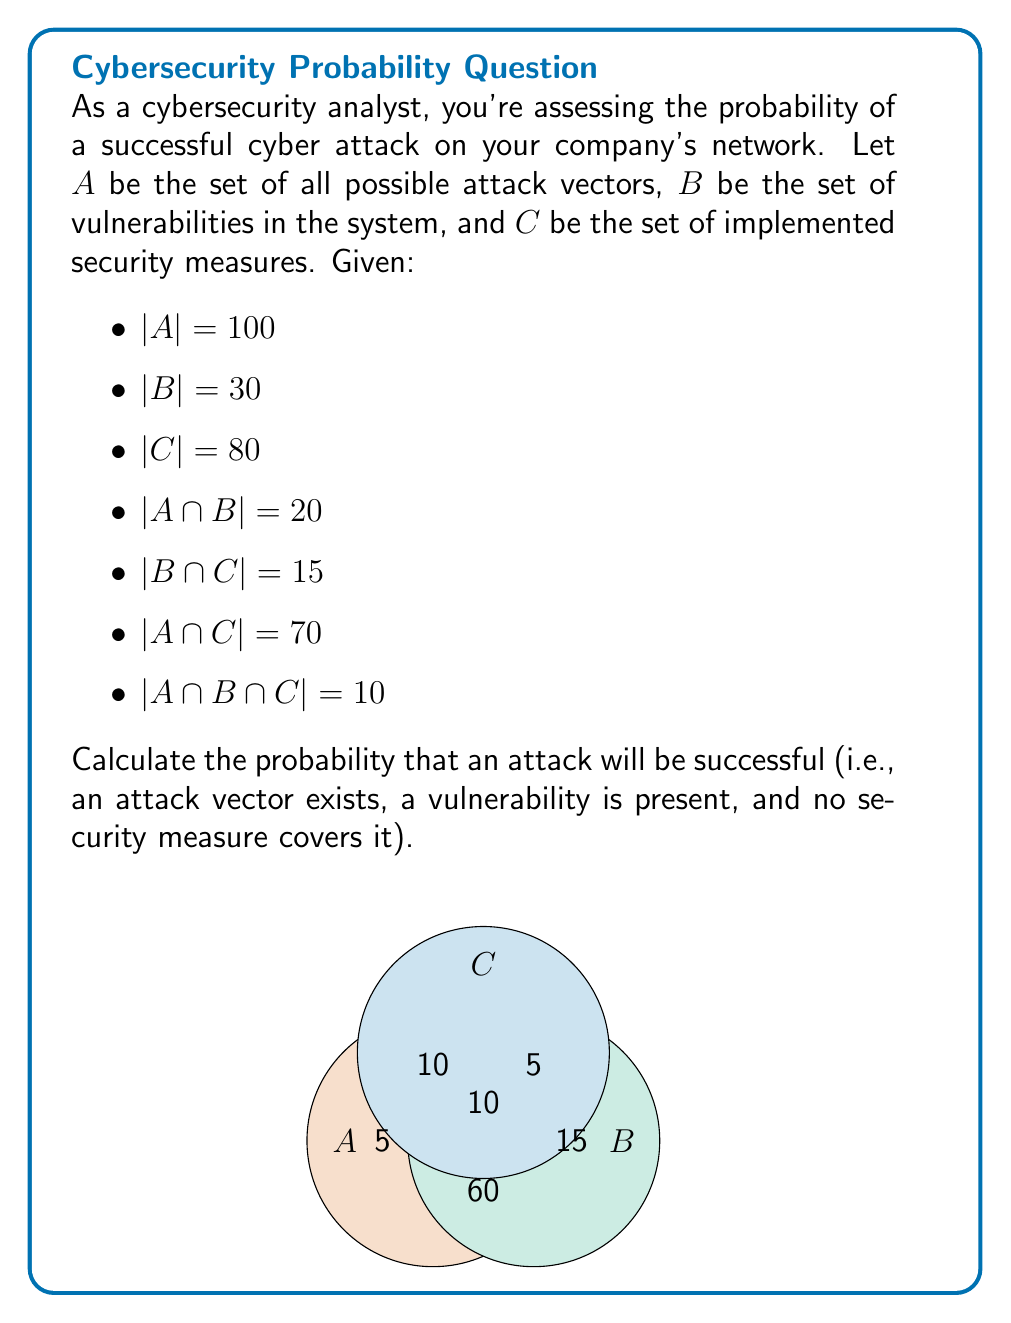Can you answer this question? Let's approach this step-by-step:

1) The successful attack probability is represented by $P((A \cap B) \setminus C)$, which means the attack vector exists (A), a vulnerability is present (B), and no security measure covers it (not C).

2) We can calculate this using the formula:

   $P((A \cap B) \setminus C) = \frac{|(A \cap B) \setminus C|}{|A|}$

3) To find $|(A \cap B) \setminus C|$, we need to calculate $|A \cap B| - |A \cap B \cap C|$:

   $|(A \cap B) \setminus C| = |A \cap B| - |A \cap B \cap C| = 20 - 10 = 10$

4) Now we can calculate the probability:

   $P((A \cap B) \setminus C) = \frac{|(A \cap B) \setminus C|}{|A|} = \frac{10}{100} = 0.1$

5) Therefore, the probability of a successful attack is 0.1 or 10%.
Answer: $0.1$ or $10\%$ 